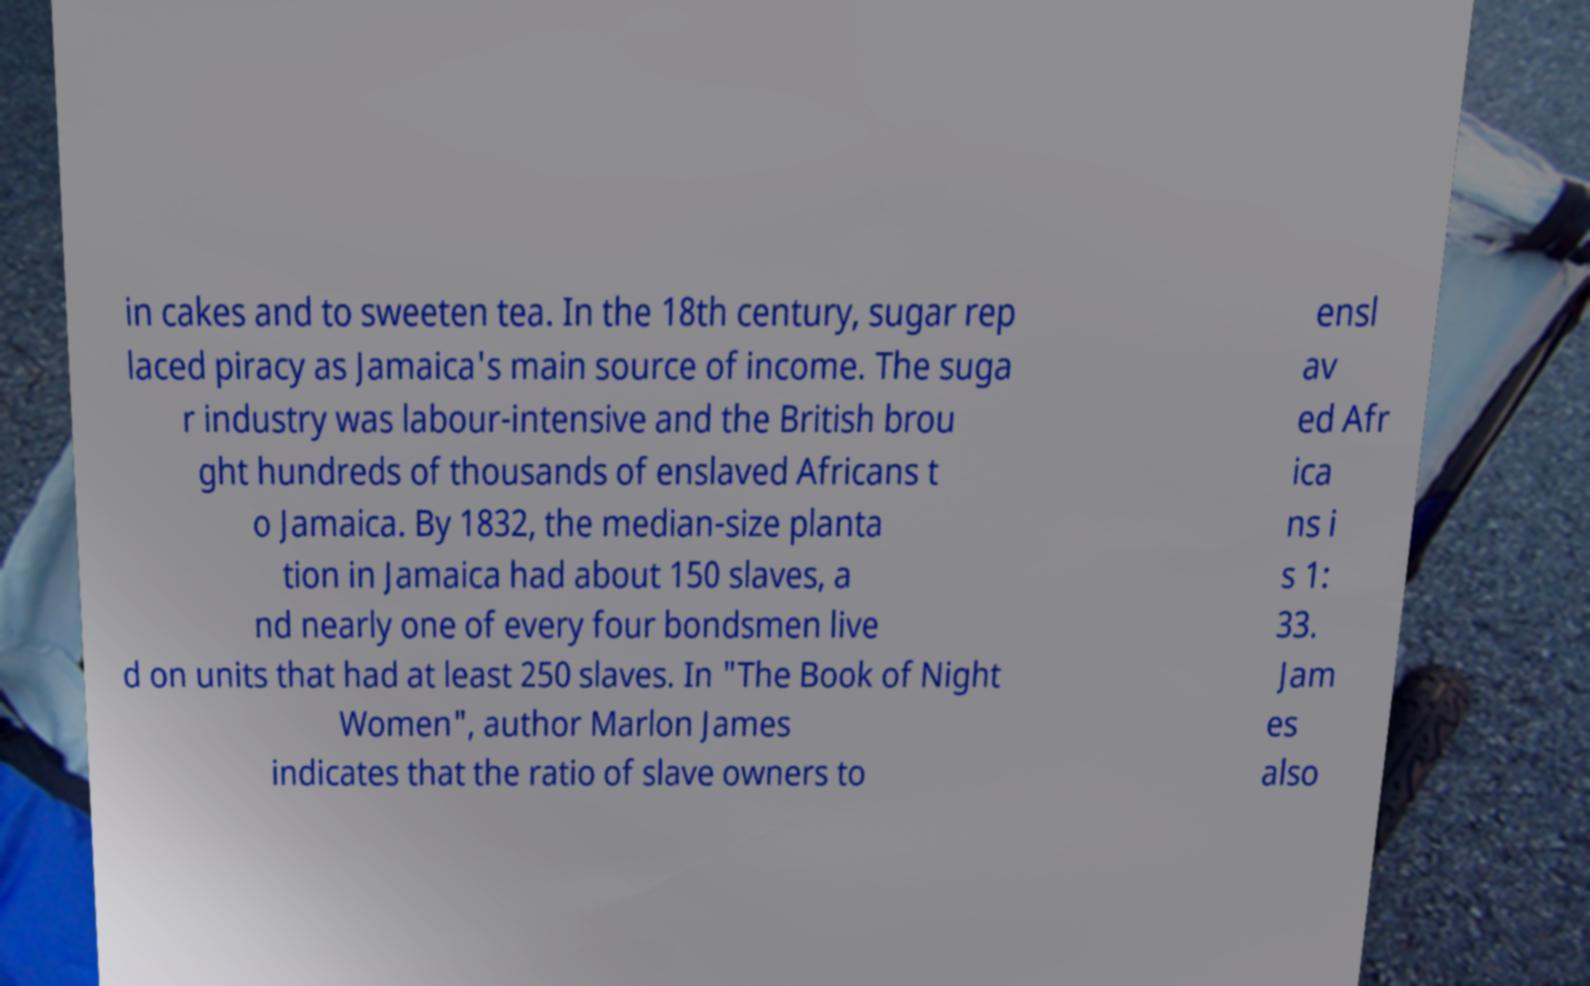Please identify and transcribe the text found in this image. in cakes and to sweeten tea. In the 18th century, sugar rep laced piracy as Jamaica's main source of income. The suga r industry was labour-intensive and the British brou ght hundreds of thousands of enslaved Africans t o Jamaica. By 1832, the median-size planta tion in Jamaica had about 150 slaves, a nd nearly one of every four bondsmen live d on units that had at least 250 slaves. In "The Book of Night Women", author Marlon James indicates that the ratio of slave owners to ensl av ed Afr ica ns i s 1: 33. Jam es also 